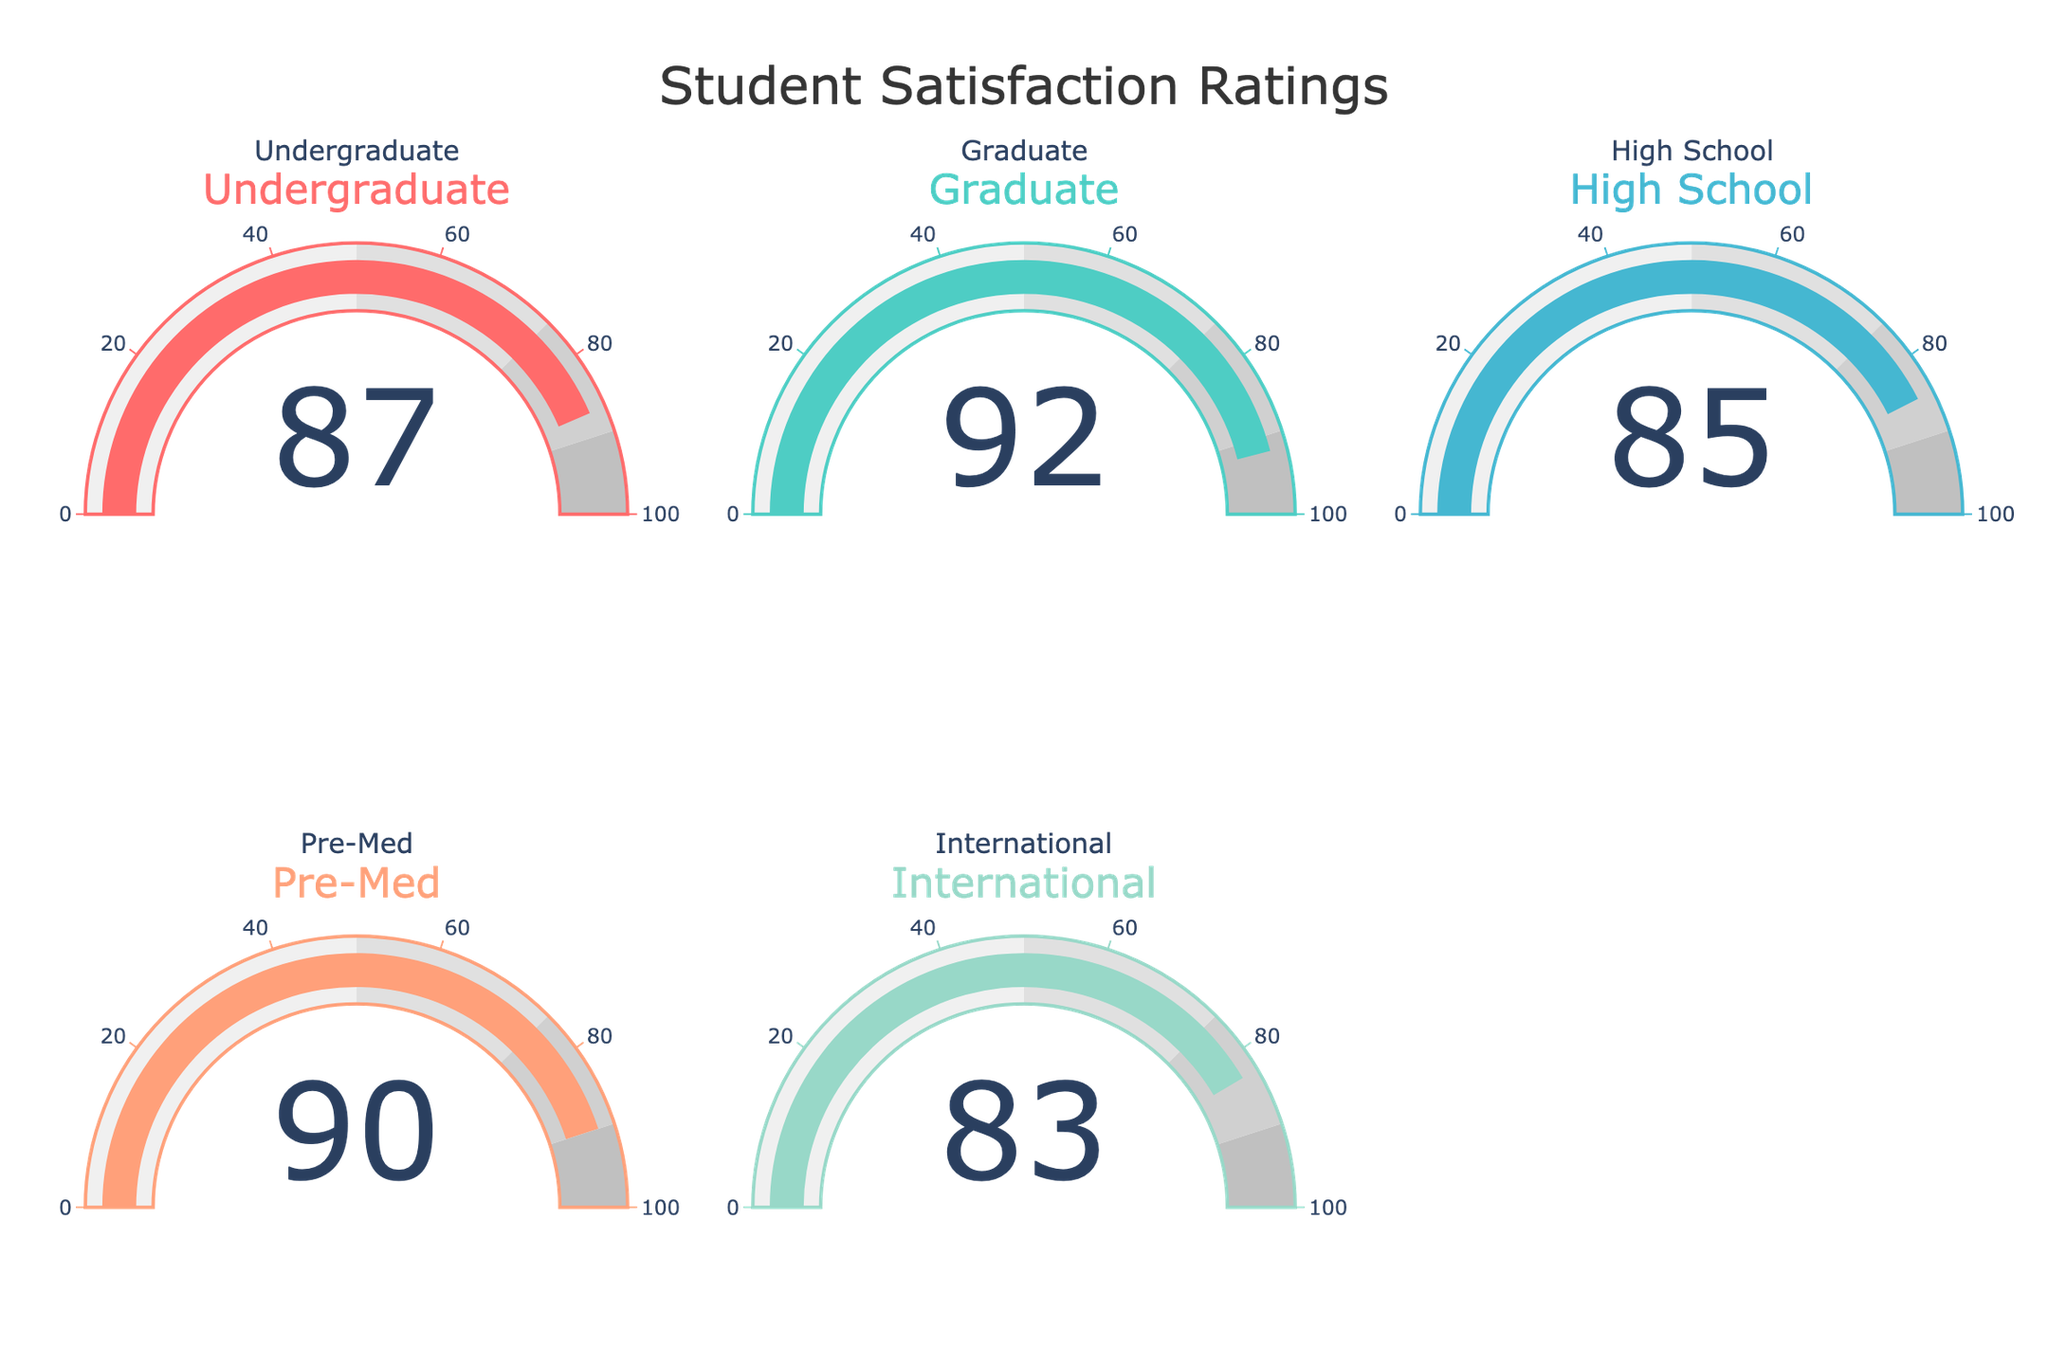Which student type has the highest satisfaction rating? The gauge chart shows ratings for different student types. The highest rating is indicated by the gauge showing 92, which belongs to Graduate students.
Answer: Graduate What is the satisfaction rating of high school students? Locate the gauge chart labeled "High School" and read the value displayed. The satisfaction rating for high school students is 85.
Answer: 85 How many student types have a satisfaction rating above 85? Count the number of gauges with values greater than 85. Undergraduate (87), Graduate (92), and Pre-Med (90) are above 85.
Answer: 3 Which student type has the lowest satisfaction rating? Observe the gauge readings and identify the lowest numeric value. The gauge for International students shows a rating of 83, which is the lowest.
Answer: International What is the sum of the satisfaction ratings for Undergraduate and Pre-Med students? Add the values of the gauges marked for Undergraduate (87) and Pre-Med (90). The sum is 87 + 90 = 177.
Answer: 177 Is the satisfaction rating for Pre-Med students greater than that for High School students? Compare the values on the Pre-Med (90) and High School (85) gauges. Since 90 is greater than 85, the answer is yes.
Answer: Yes Calculate the average satisfaction rating across all student types. Sum all the ratings and divide by the number of student types: (87 + 92 + 85 + 90 + 83) / 5 = 437 / 5 = 87.4
Answer: 87.4 Between Graduate and International students, who has a higher satisfaction rating and by how much? Compare the values for Graduate (92) and International (83). The difference is 92 - 83 = 9.
Answer: Graduate, by 9 